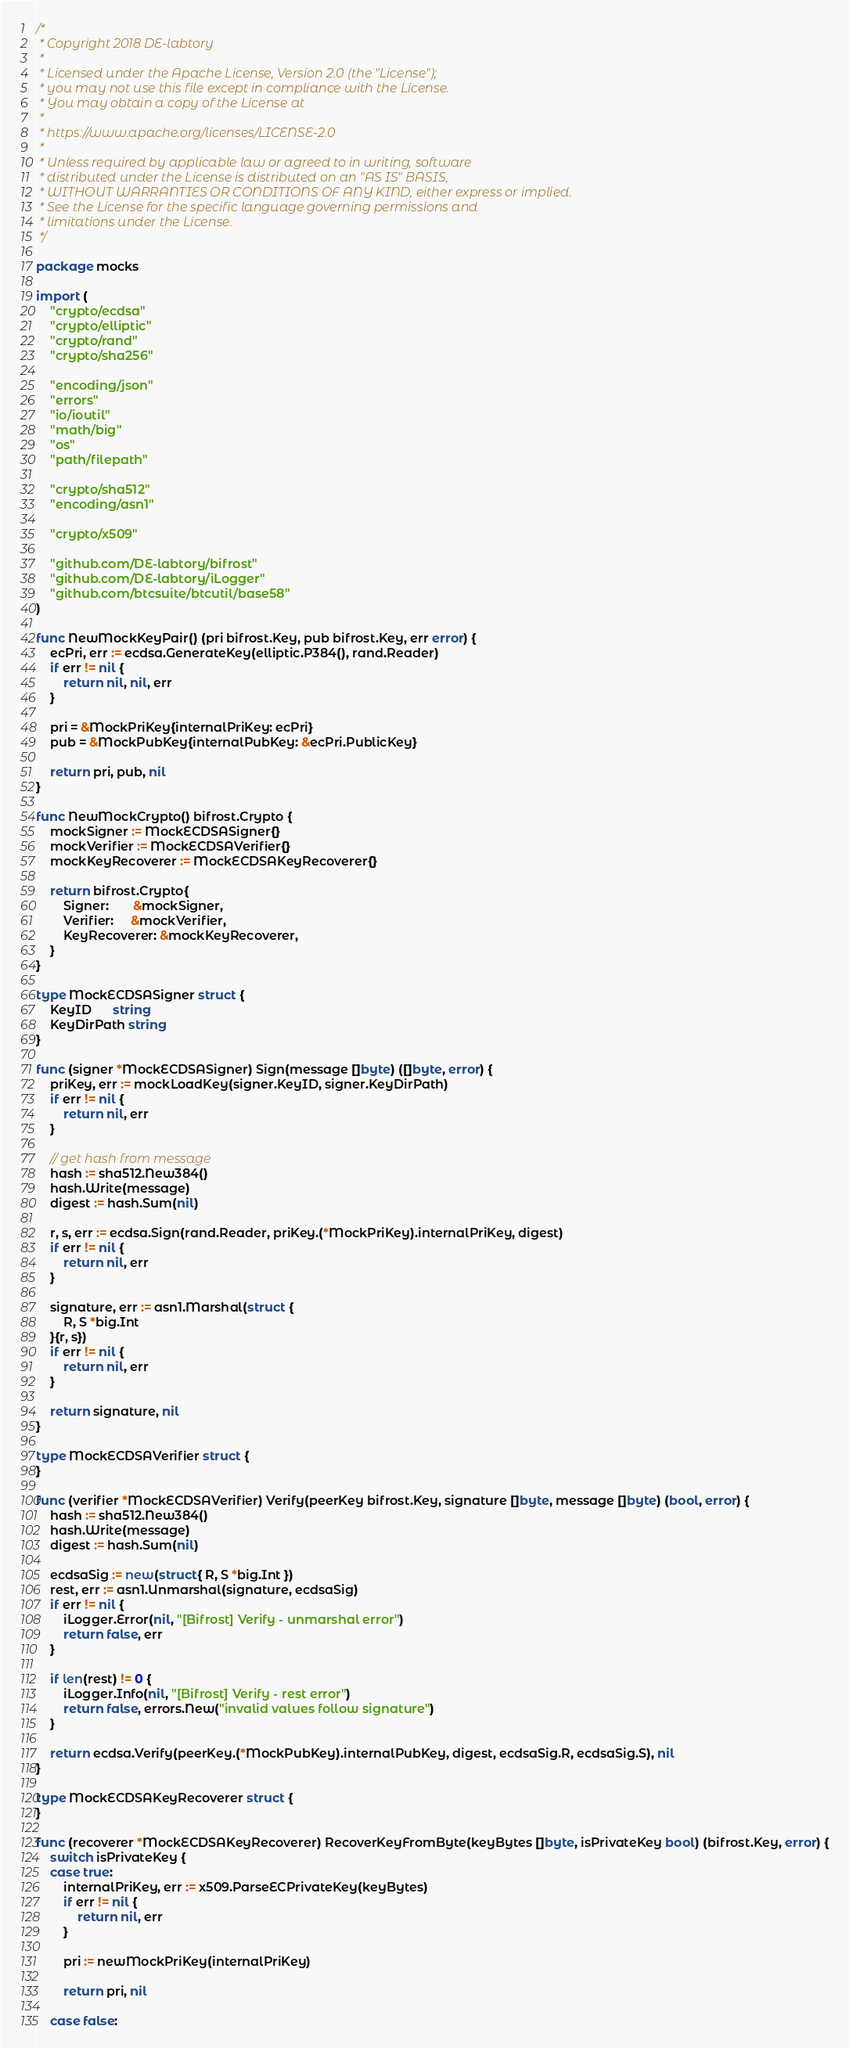<code> <loc_0><loc_0><loc_500><loc_500><_Go_>/*
 * Copyright 2018 DE-labtory
 *
 * Licensed under the Apache License, Version 2.0 (the "License");
 * you may not use this file except in compliance with the License.
 * You may obtain a copy of the License at
 *
 * https://www.apache.org/licenses/LICENSE-2.0
 *
 * Unless required by applicable law or agreed to in writing, software
 * distributed under the License is distributed on an "AS IS" BASIS,
 * WITHOUT WARRANTIES OR CONDITIONS OF ANY KIND, either express or implied.
 * See the License for the specific language governing permissions and
 * limitations under the License.
 */

package mocks

import (
	"crypto/ecdsa"
	"crypto/elliptic"
	"crypto/rand"
	"crypto/sha256"

	"encoding/json"
	"errors"
	"io/ioutil"
	"math/big"
	"os"
	"path/filepath"

	"crypto/sha512"
	"encoding/asn1"

	"crypto/x509"

	"github.com/DE-labtory/bifrost"
	"github.com/DE-labtory/iLogger"
	"github.com/btcsuite/btcutil/base58"
)

func NewMockKeyPair() (pri bifrost.Key, pub bifrost.Key, err error) {
	ecPri, err := ecdsa.GenerateKey(elliptic.P384(), rand.Reader)
	if err != nil {
		return nil, nil, err
	}

	pri = &MockPriKey{internalPriKey: ecPri}
	pub = &MockPubKey{internalPubKey: &ecPri.PublicKey}

	return pri, pub, nil
}

func NewMockCrypto() bifrost.Crypto {
	mockSigner := MockECDSASigner{}
	mockVerifier := MockECDSAVerifier{}
	mockKeyRecoverer := MockECDSAKeyRecoverer{}

	return bifrost.Crypto{
		Signer:       &mockSigner,
		Verifier:     &mockVerifier,
		KeyRecoverer: &mockKeyRecoverer,
	}
}

type MockECDSASigner struct {
	KeyID      string
	KeyDirPath string
}

func (signer *MockECDSASigner) Sign(message []byte) ([]byte, error) {
	priKey, err := mockLoadKey(signer.KeyID, signer.KeyDirPath)
	if err != nil {
		return nil, err
	}

	// get hash from message
	hash := sha512.New384()
	hash.Write(message)
	digest := hash.Sum(nil)

	r, s, err := ecdsa.Sign(rand.Reader, priKey.(*MockPriKey).internalPriKey, digest)
	if err != nil {
		return nil, err
	}

	signature, err := asn1.Marshal(struct {
		R, S *big.Int
	}{r, s})
	if err != nil {
		return nil, err
	}

	return signature, nil
}

type MockECDSAVerifier struct {
}

func (verifier *MockECDSAVerifier) Verify(peerKey bifrost.Key, signature []byte, message []byte) (bool, error) {
	hash := sha512.New384()
	hash.Write(message)
	digest := hash.Sum(nil)

	ecdsaSig := new(struct{ R, S *big.Int })
	rest, err := asn1.Unmarshal(signature, ecdsaSig)
	if err != nil {
		iLogger.Error(nil, "[Bifrost] Verify - unmarshal error")
		return false, err
	}

	if len(rest) != 0 {
		iLogger.Info(nil, "[Bifrost] Verify - rest error")
		return false, errors.New("invalid values follow signature")
	}

	return ecdsa.Verify(peerKey.(*MockPubKey).internalPubKey, digest, ecdsaSig.R, ecdsaSig.S), nil
}

type MockECDSAKeyRecoverer struct {
}

func (recoverer *MockECDSAKeyRecoverer) RecoverKeyFromByte(keyBytes []byte, isPrivateKey bool) (bifrost.Key, error) {
	switch isPrivateKey {
	case true:
		internalPriKey, err := x509.ParseECPrivateKey(keyBytes)
		if err != nil {
			return nil, err
		}

		pri := newMockPriKey(internalPriKey)

		return pri, nil

	case false:</code> 